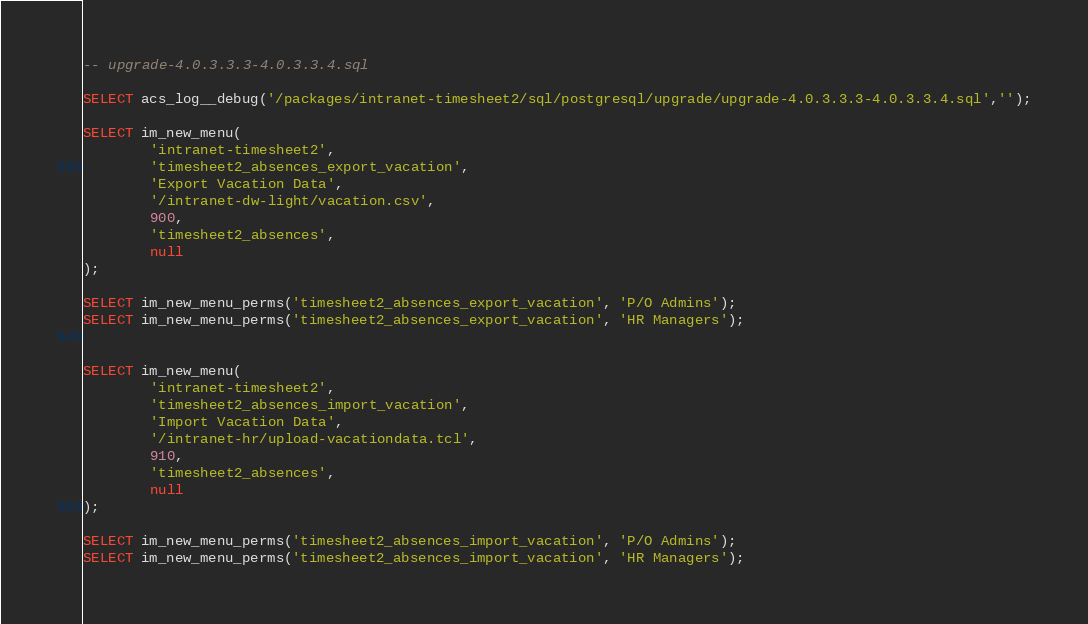<code> <loc_0><loc_0><loc_500><loc_500><_SQL_>-- upgrade-4.0.3.3.3-4.0.3.3.4.sql

SELECT acs_log__debug('/packages/intranet-timesheet2/sql/postgresql/upgrade/upgrade-4.0.3.3.3-4.0.3.3.4.sql','');
		
SELECT im_new_menu(
        'intranet-timesheet2',
        'timesheet2_absences_export_vacation',
        'Export Vacation Data',
        '/intranet-dw-light/vacation.csv',
        900,
        'timesheet2_absences',
        null
);

SELECT im_new_menu_perms('timesheet2_absences_export_vacation', 'P/O Admins');
SELECT im_new_menu_perms('timesheet2_absences_export_vacation', 'HR Managers');


SELECT im_new_menu(
        'intranet-timesheet2',
        'timesheet2_absences_import_vacation',
        'Import Vacation Data',
        '/intranet-hr/upload-vacationdata.tcl',
        910,
        'timesheet2_absences',
        null
);

SELECT im_new_menu_perms('timesheet2_absences_import_vacation', 'P/O Admins');
SELECT im_new_menu_perms('timesheet2_absences_import_vacation', 'HR Managers');
</code> 